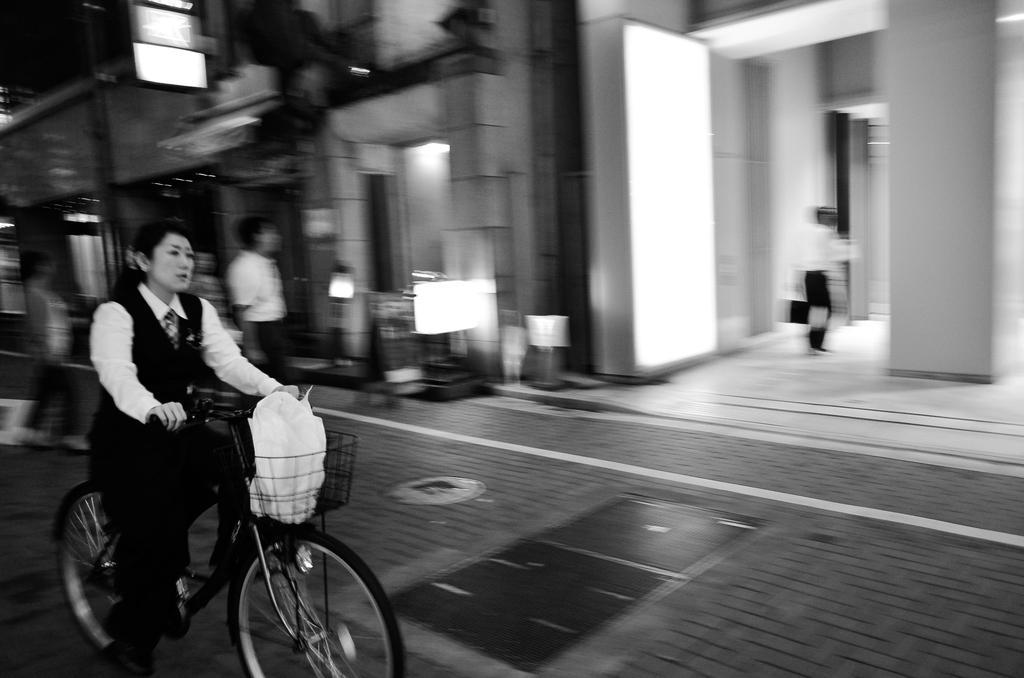In one or two sentences, can you explain what this image depicts? this picture shows a woman riding bicycle and we see a man walking into the building and we see a man standing and we see a hoarding 